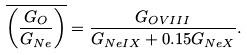Convert formula to latex. <formula><loc_0><loc_0><loc_500><loc_500>\overline { \left ( \frac { G _ { O } } { G _ { N e } } \right ) } = \frac { G _ { O V I I I } } { G _ { N e I X } + 0 . 1 5 G _ { N e X } } .</formula> 